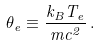<formula> <loc_0><loc_0><loc_500><loc_500>\theta _ { e } \equiv \frac { k _ { B } T _ { e } } { m c ^ { 2 } } \, .</formula> 